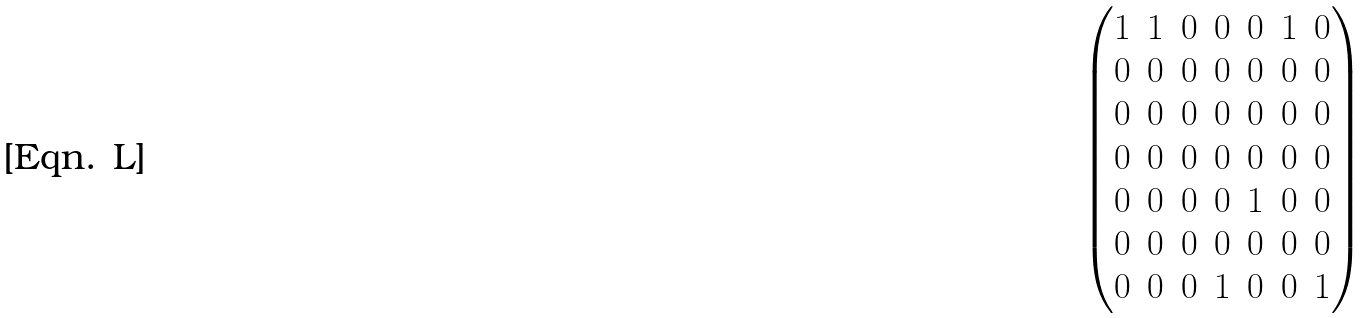Convert formula to latex. <formula><loc_0><loc_0><loc_500><loc_500>\begin{pmatrix} 1 & 1 & 0 & 0 & 0 & 1 & 0 \\ 0 & 0 & 0 & 0 & 0 & 0 & 0 \\ 0 & 0 & 0 & 0 & 0 & 0 & 0 \\ 0 & 0 & 0 & 0 & 0 & 0 & 0 \\ 0 & 0 & 0 & 0 & 1 & 0 & 0 \\ 0 & 0 & 0 & 0 & 0 & 0 & 0 \\ 0 & 0 & 0 & 1 & 0 & 0 & 1 \end{pmatrix}</formula> 